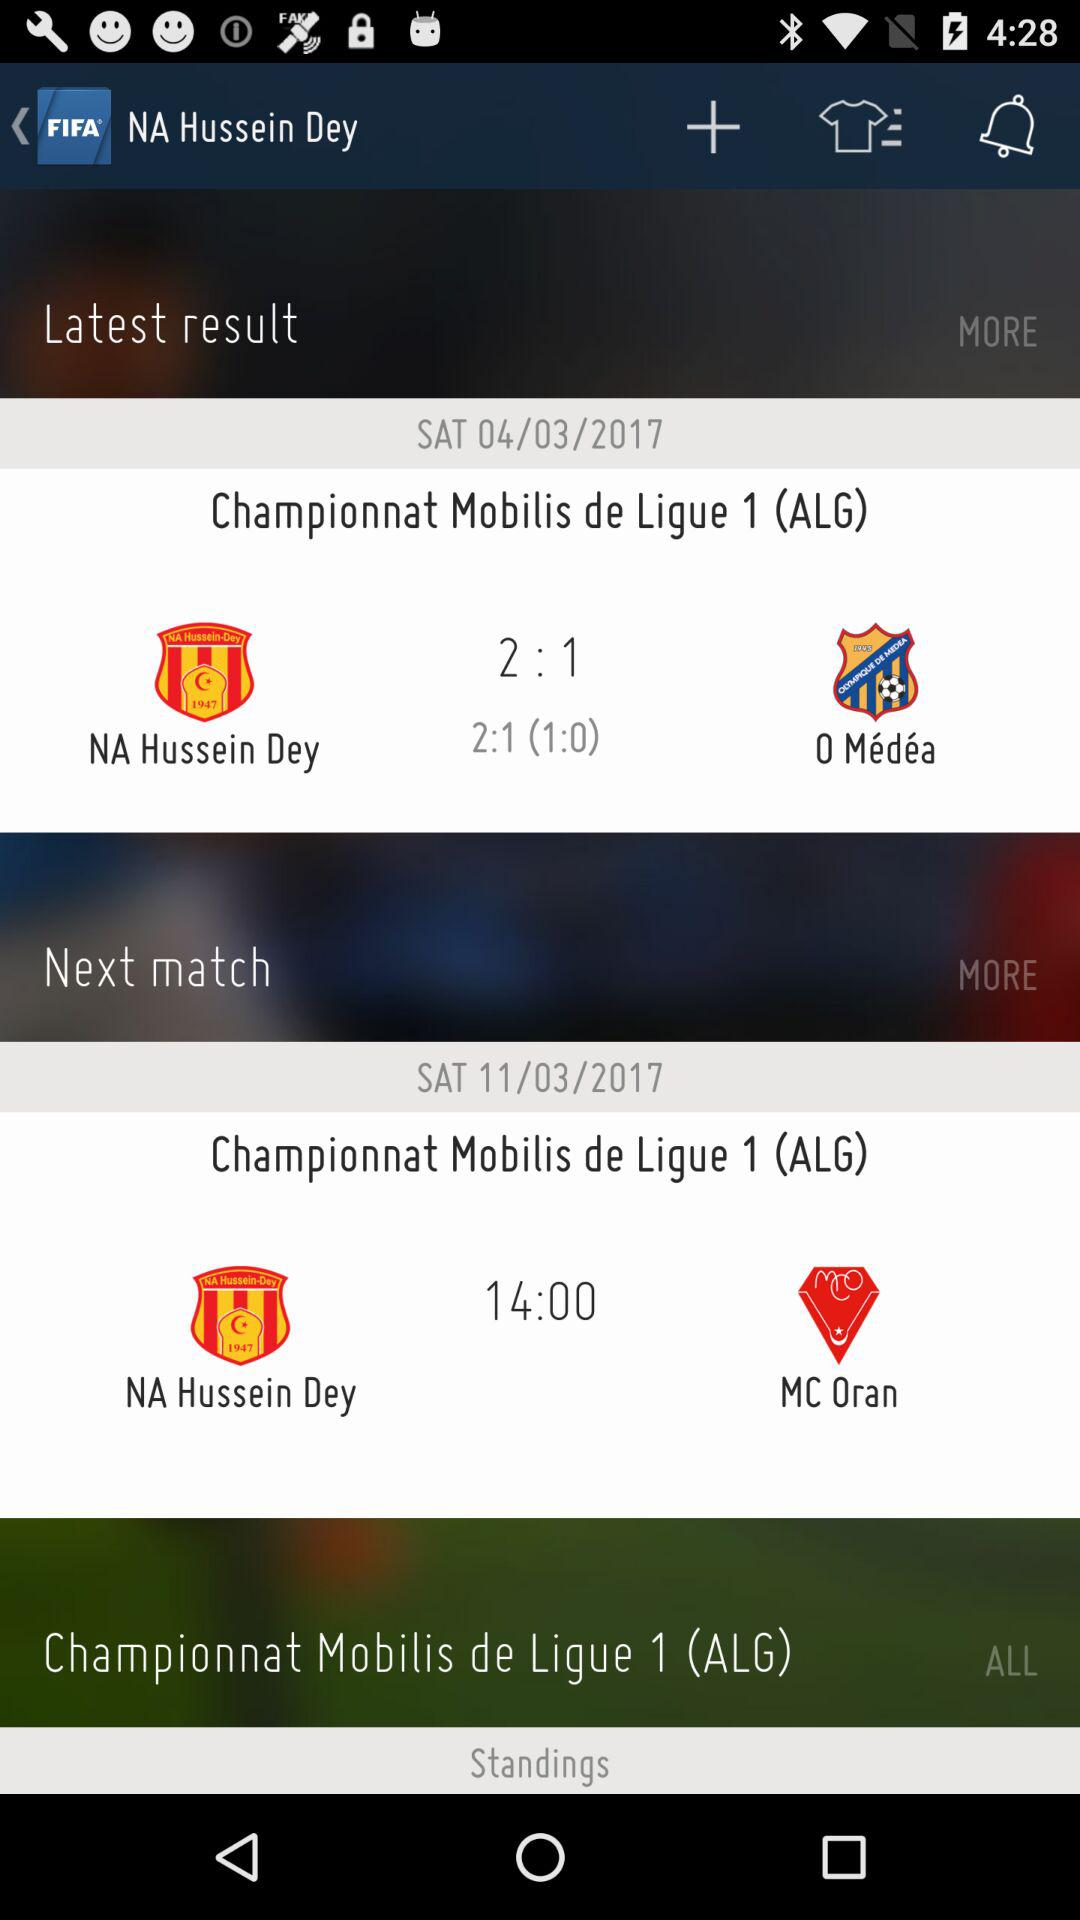What is the name of the application? The name of the application is "FIFA". 